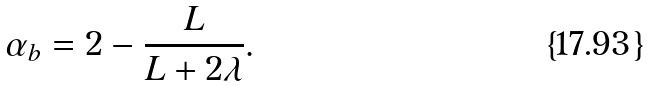<formula> <loc_0><loc_0><loc_500><loc_500>\alpha _ { b } = 2 - \frac { L } { L + 2 \lambda } .</formula> 